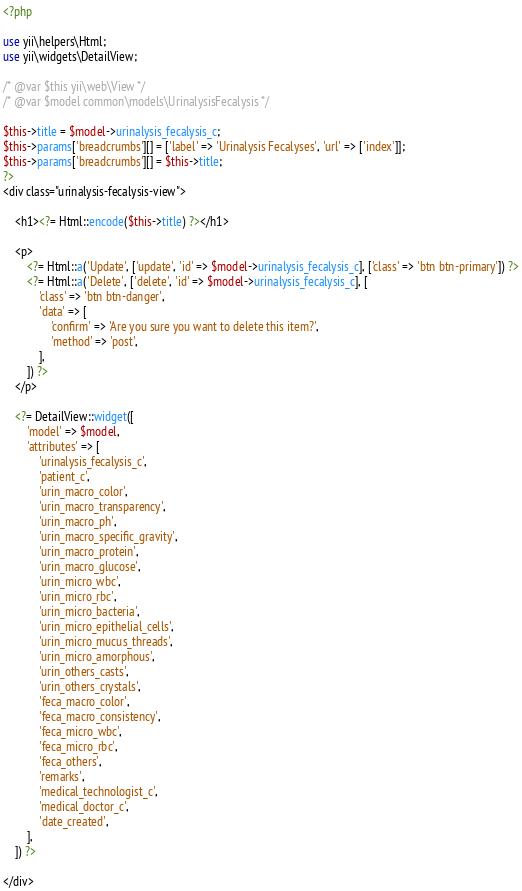Convert code to text. <code><loc_0><loc_0><loc_500><loc_500><_PHP_><?php

use yii\helpers\Html;
use yii\widgets\DetailView;

/* @var $this yii\web\View */
/* @var $model common\models\UrinalysisFecalysis */

$this->title = $model->urinalysis_fecalysis_c;
$this->params['breadcrumbs'][] = ['label' => 'Urinalysis Fecalyses', 'url' => ['index']];
$this->params['breadcrumbs'][] = $this->title;
?>
<div class="urinalysis-fecalysis-view">

    <h1><?= Html::encode($this->title) ?></h1>

    <p>
        <?= Html::a('Update', ['update', 'id' => $model->urinalysis_fecalysis_c], ['class' => 'btn btn-primary']) ?>
        <?= Html::a('Delete', ['delete', 'id' => $model->urinalysis_fecalysis_c], [
            'class' => 'btn btn-danger',
            'data' => [
                'confirm' => 'Are you sure you want to delete this item?',
                'method' => 'post',
            ],
        ]) ?>
    </p>

    <?= DetailView::widget([
        'model' => $model,
        'attributes' => [
            'urinalysis_fecalysis_c',
            'patient_c',
            'urin_macro_color',
            'urin_macro_transparency',
            'urin_macro_ph',
            'urin_macro_specific_gravity',
            'urin_macro_protein',
            'urin_macro_glucose',
            'urin_micro_wbc',
            'urin_micro_rbc',
            'urin_micro_bacteria',
            'urin_micro_epithelial_cells',
            'urin_micro_mucus_threads',
            'urin_micro_amorphous',
            'urin_others_casts',
            'urin_others_crystals',
            'feca_macro_color',
            'feca_macro_consistency',
            'feca_micro_wbc',
            'feca_micro_rbc',
            'feca_others',
            'remarks',
            'medical_technologist_c',
            'medical_doctor_c',
            'date_created',
        ],
    ]) ?>

</div>
</code> 